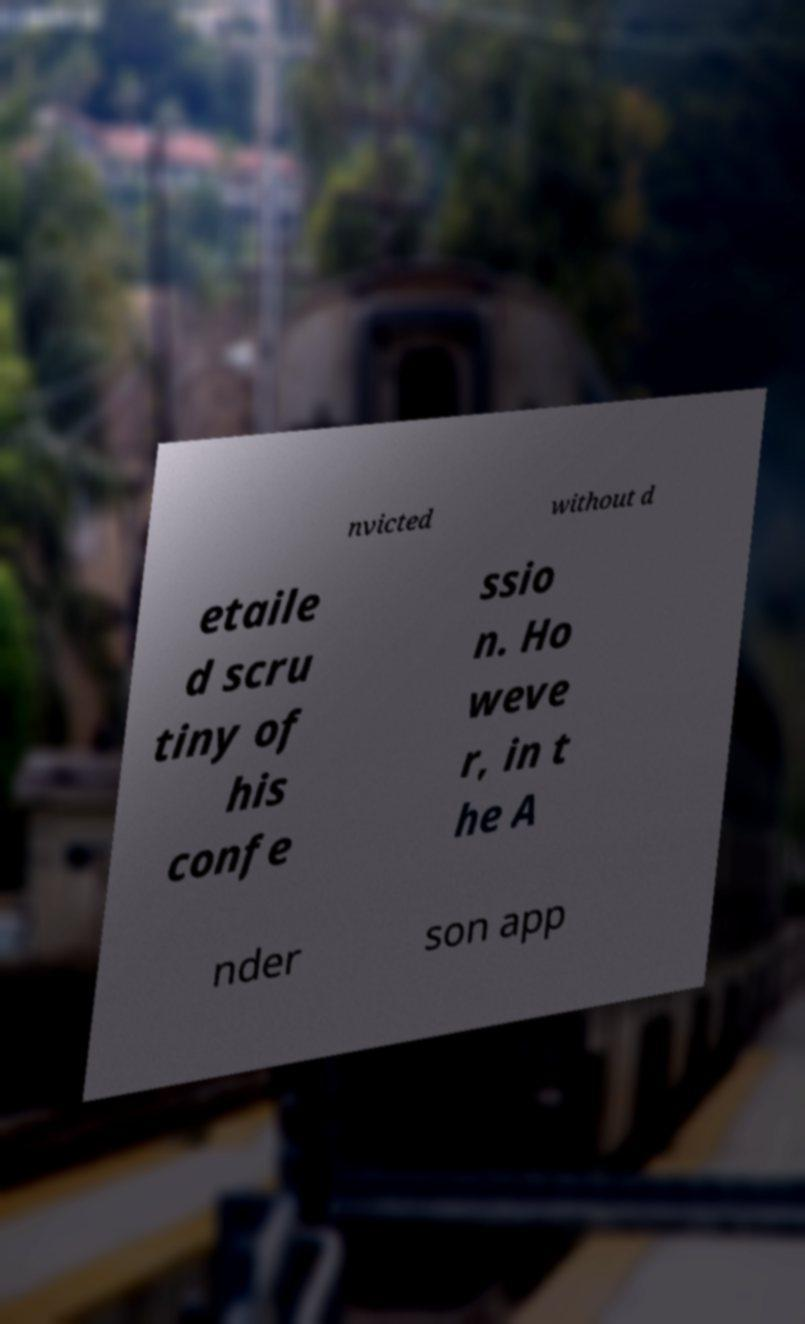What messages or text are displayed in this image? I need them in a readable, typed format. nvicted without d etaile d scru tiny of his confe ssio n. Ho weve r, in t he A nder son app 